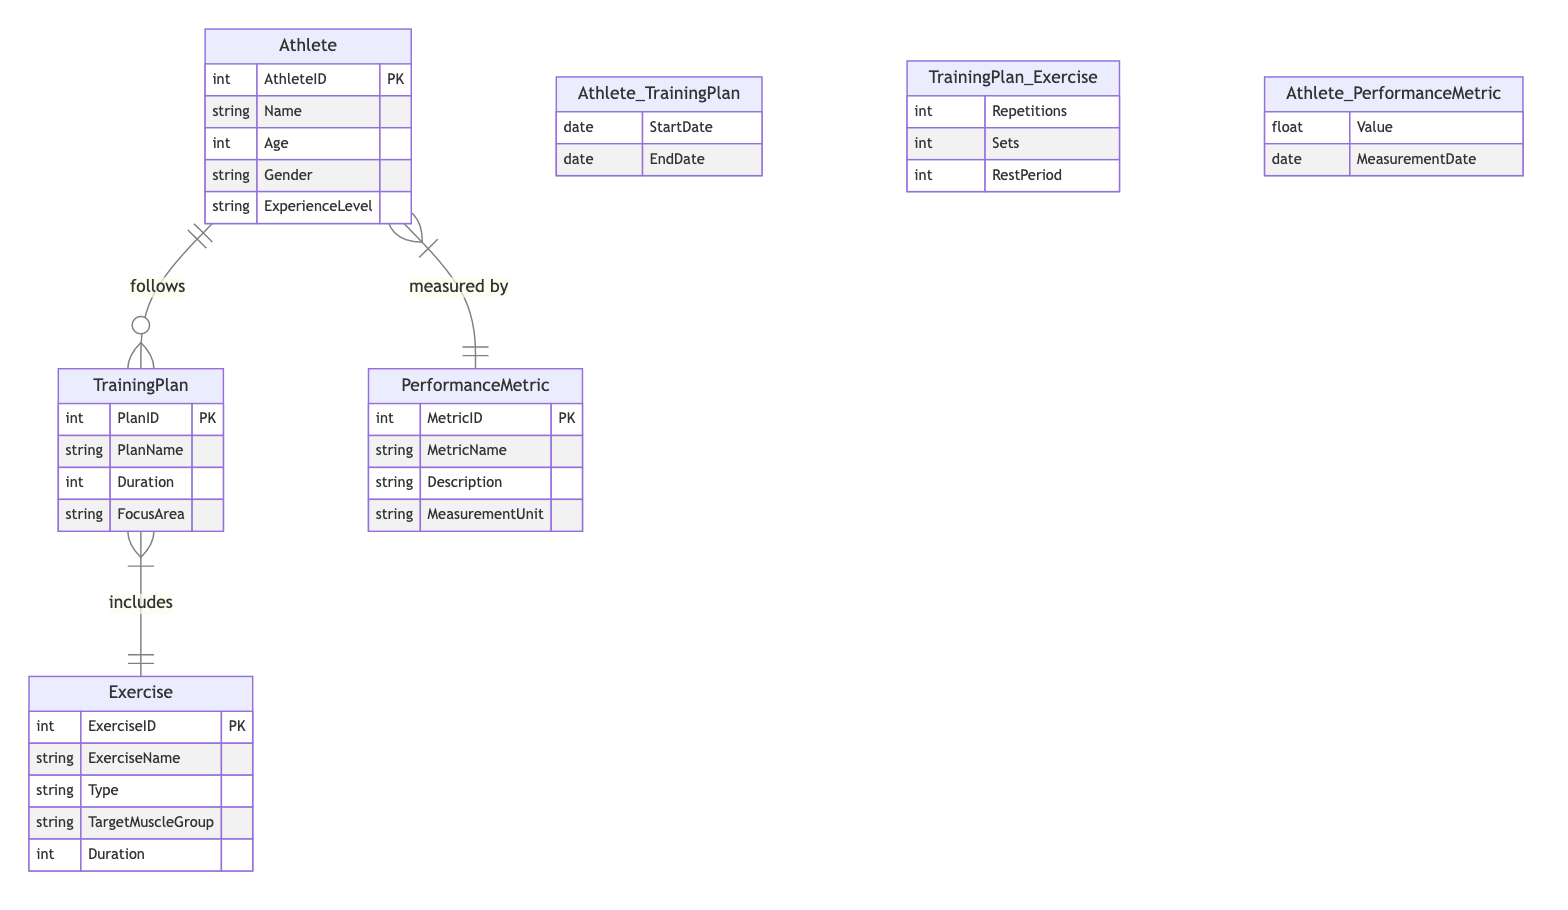What is the primary relationship between Athlete and Training Plan? The diagram specifies that the relationship between Athlete and Training Plan is "follows," indicating that one athlete can have multiple training plans over time.
Answer: follows How many attributes does the Exercise entity have? By inspecting the Exercise entity section of the diagram, it shows a list that includes ExerciseID, ExerciseName, Type, TargetMuscleGroup, and Duration, totaling five attributes.
Answer: five What type of relationship exists between Training Plan and Exercise? The diagram illustrates a many-to-many relationship between Training Plan and Exercise, represented by the symbol indicating that one training plan can include multiple exercises and vice versa.
Answer: many-to-many What additional information is captured in the Athlete_TrainingPlan relationship? This relationship includes attributes such as StartDate and EndDate, which show the time frame for each athlete's engagement with a training plan.
Answer: StartDate, EndDate Which entity is related to Performance Metric as "measured by"? The diagram notes that the Athlete entity is connected to Performance Metric with the label "measured by," indicating that performance metrics track the results of athletes.
Answer: Athlete What is the Focus Area attribute in the Training Plan entity? In the Training Plan entity, Focus Area describes the specific area of training targeted in the plan, indicating whether it focuses on endurance, speed, strength, etc.
Answer: Focus Area How many total entities are defined in the diagram? By counting the entities listed in the diagram, there are four distinct entities: Athlete, Training Plan, Exercise, and Performance Metric, which totals four entities.
Answer: four What minimal data is recorded in the Athlete_PerformanceMetric relationship? The Athlete_PerformanceMetric relationship stores minimal data elements, capturing the athlete's Value and MeasurementDate to track performance over time.
Answer: Value, MeasurementDate What type of exercise can be included in a Training Plan? The diagram specifies exercises can be categorized by different types (like aerobic, strength training, etc.), as indicated in the attributes of the Exercise entity.
Answer: Type 